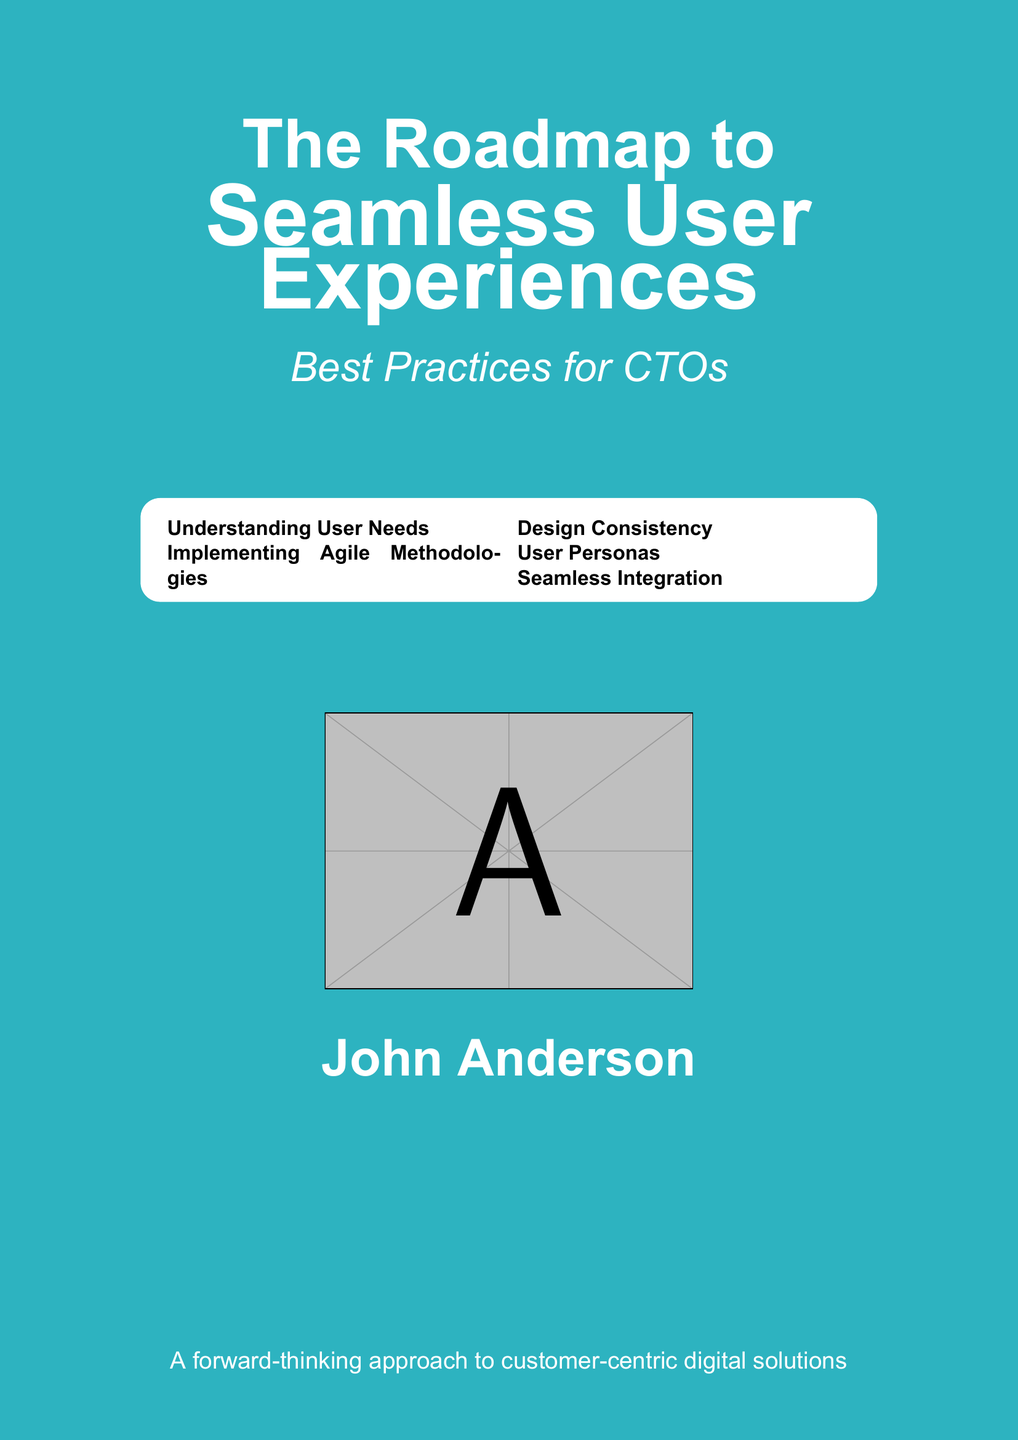What is the title of the book? The title is prominently displayed at the top of the document.
Answer: The Roadmap to Seamless User Experiences Who is the author? The author's name is centered and identified at the bottom of the cover.
Answer: John Anderson What is the subtitle of the book? The subtitle is listed below the main title and highlights the target audience.
Answer: Best Practices for CTOs How many key topics are presented in the tcolorbox? The number of key topics can be counted in the box.
Answer: Five What color scheme is used in the background? The background color is a combination of deep blue and light turquoise.
Answer: Deep blue and light turquoise What is the emphasis of the book? The book's emphasis can be inferred from the subtext.
Answer: Customer-centric digital solutions Which design element connects the content visually? The document features a design style that connects information elements.
Answer: Smooth gradient Is there a visual element included on the cover? The presence of an image can be noted from the mention in the document.
Answer: Yes What type of document is this? The specific format this document follows is described in the content.
Answer: Book cover 